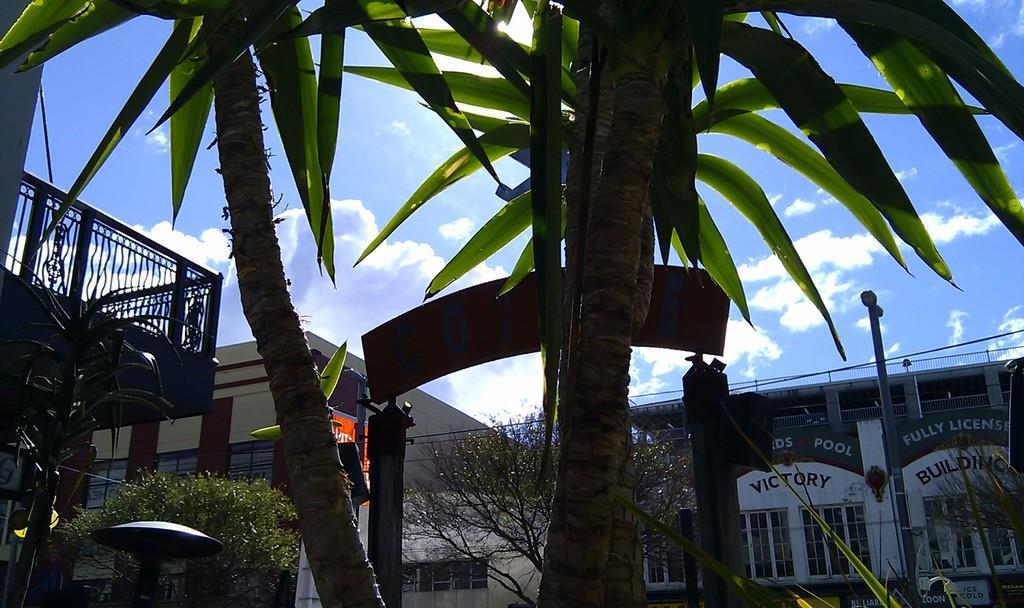How would you summarize this image in a sentence or two? In this image I can see there are buildings and trees. And in between the trees there is an object. And there is a current pole and wires tied to it. And there is a light pole. And at the top there is a sky. 